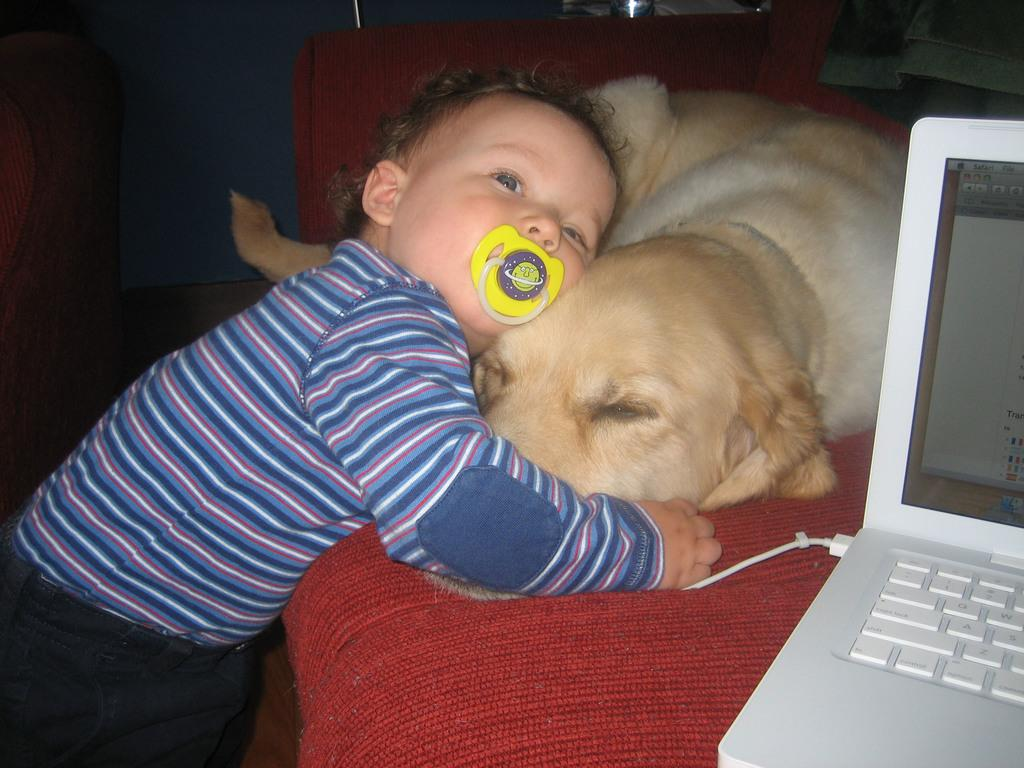Where is the kid located in the image? The kid is standing on the bottom left side of the image. What is the kid holding in the image? The kid is holding a dog in the image. What piece of furniture is in the middle of the image? There is a couch in the middle of the image. What electronic device is on the bottom right side of the couch? There is a laptop on the bottom right side of the couch. What type of payment is being made by the fireman in the image? There is no fireman present in the image, and therefore no payment being made. What is the dog doing with its tongue in the image? The dog is not depicted doing anything with its tongue in the image; it is simply being held by the kid. 